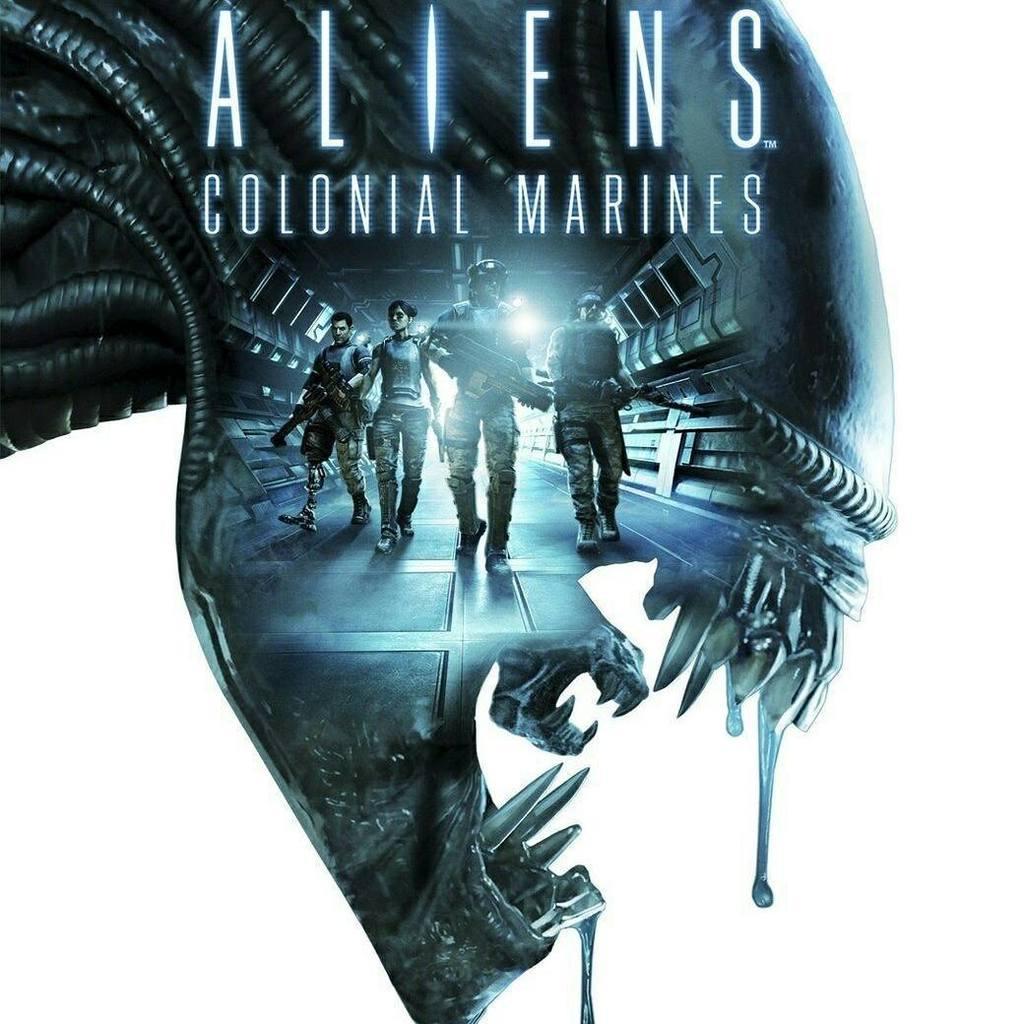Could you give a brief overview of what you see in this image? In this picture I can see a sculpture on which I can see some persons and some text. 